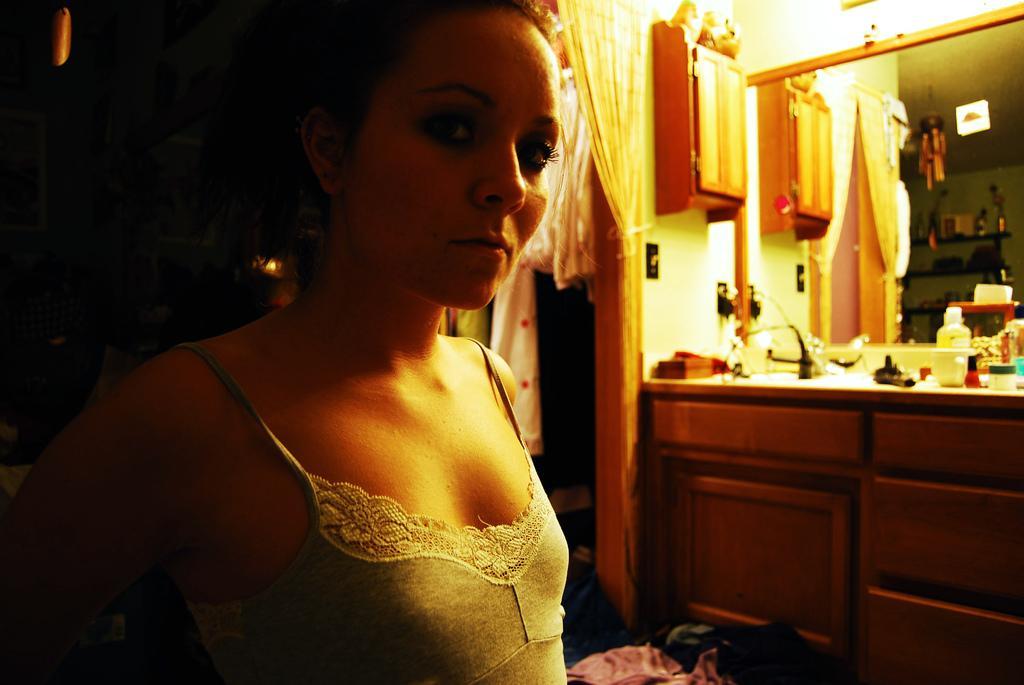Can you describe this image briefly? In the foreground of this image, there is a woman in grey colored dress and on the right side of the image, there are curtain, cupboard, few cosmetics and a mirror. 